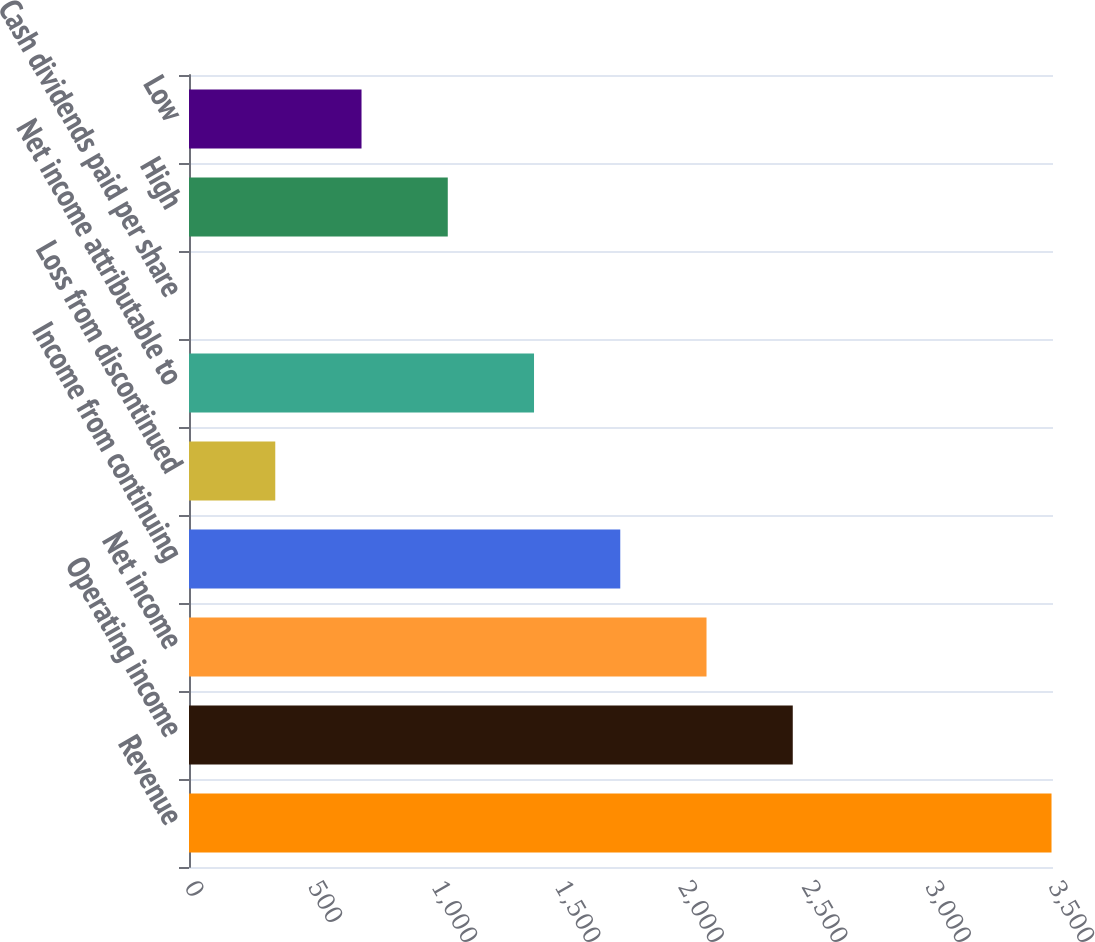<chart> <loc_0><loc_0><loc_500><loc_500><bar_chart><fcel>Revenue<fcel>Operating income<fcel>Net income<fcel>Income from continuing<fcel>Loss from discontinued<fcel>Net income attributable to<fcel>Cash dividends paid per share<fcel>High<fcel>Low<nl><fcel>3494<fcel>2445.82<fcel>2096.43<fcel>1747.04<fcel>349.48<fcel>1397.65<fcel>0.09<fcel>1048.26<fcel>698.87<nl></chart> 